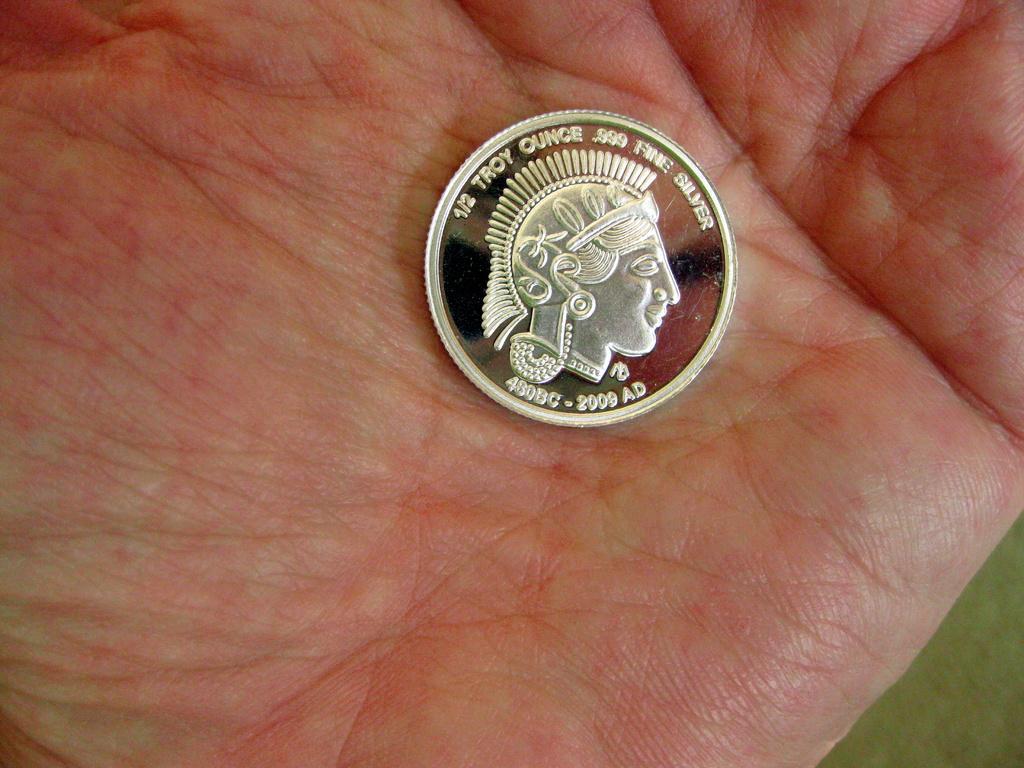In one or two sentences, can you explain what this image depicts? In this image I can see a currency coin which is silver in color on a human hand which is red and cream in color. 